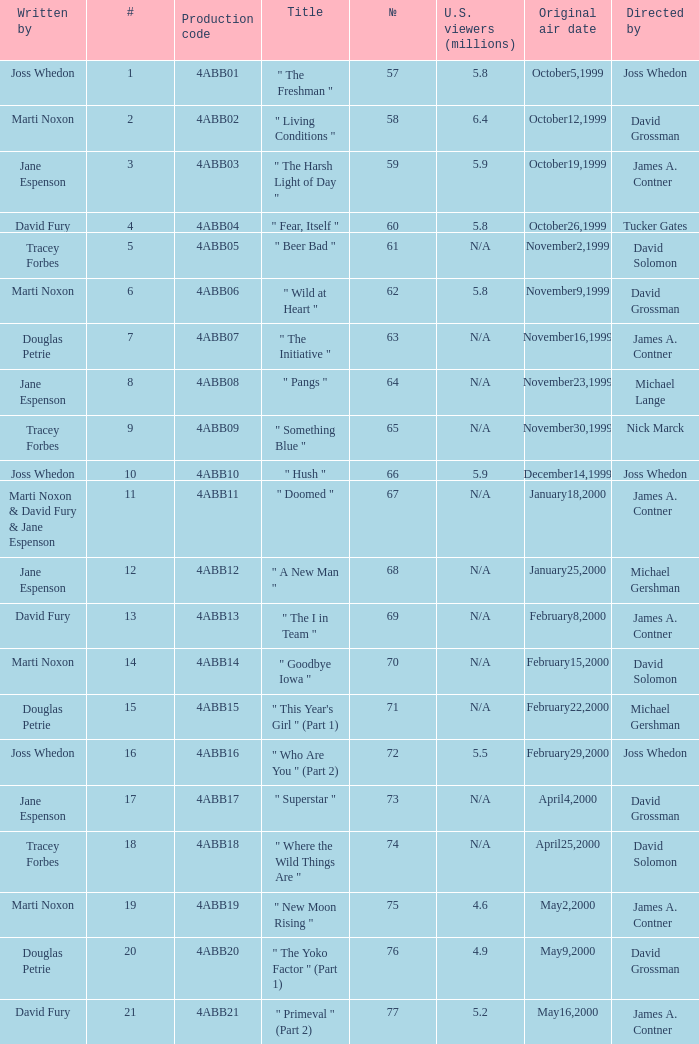What is the title of episode No. 65? " Something Blue ". 